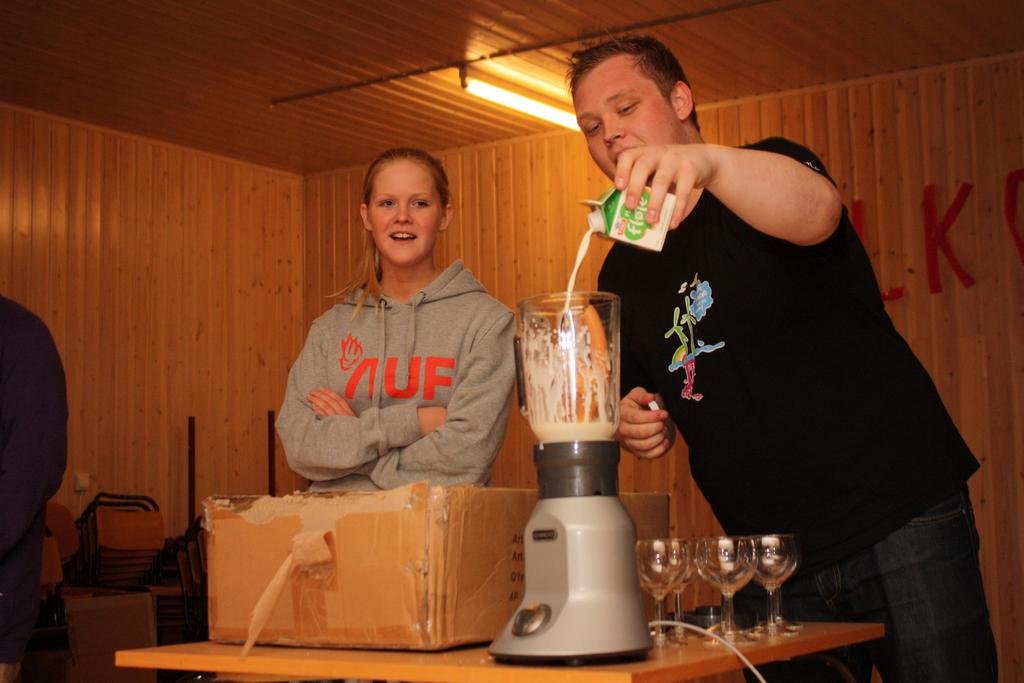What is on her hoodie?
Your answer should be compact. Auf. 